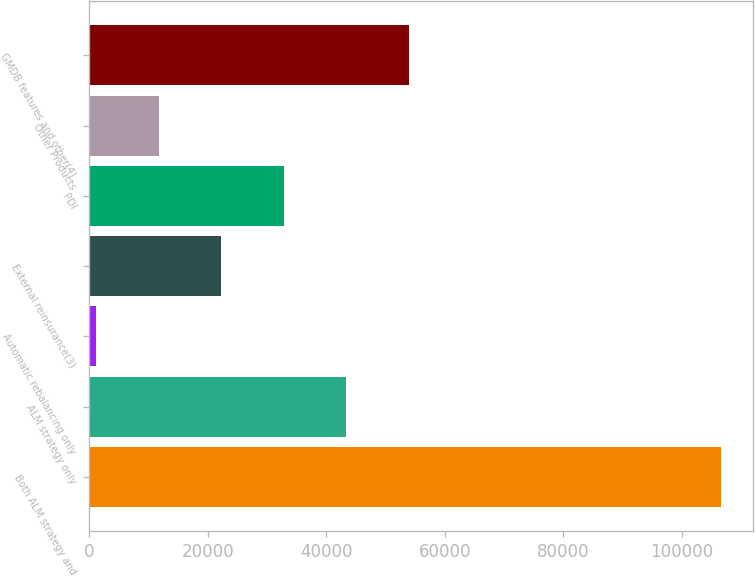Convert chart to OTSL. <chart><loc_0><loc_0><loc_500><loc_500><bar_chart><fcel>Both ALM strategy and<fcel>ALM strategy only<fcel>Automatic rebalancing only<fcel>External reinsurance(3)<fcel>PDI<fcel>Other Products<fcel>GMDB features and other(4)<nl><fcel>106585<fcel>43334.8<fcel>1168<fcel>22251.4<fcel>32793.1<fcel>11709.7<fcel>53876.5<nl></chart> 